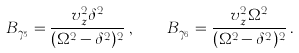<formula> <loc_0><loc_0><loc_500><loc_500>B _ { \gamma _ { 5 } } = \frac { v _ { z } ^ { 2 } \delta ^ { 2 } } { ( \Omega ^ { 2 } - \delta ^ { 2 } ) ^ { 2 } } \, , \quad B _ { \gamma _ { 6 } } = \frac { v _ { z } ^ { 2 } \Omega ^ { 2 } } { ( \Omega ^ { 2 } - \delta ^ { 2 } ) ^ { 2 } } \, .</formula> 